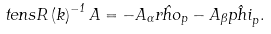Convert formula to latex. <formula><loc_0><loc_0><loc_500><loc_500>\ t e n s R \left ( k \right ) ^ { - 1 } A = - A _ { \alpha } \hat { r h o } _ { p } - A _ { \beta } \hat { p h i } _ { p } .</formula> 